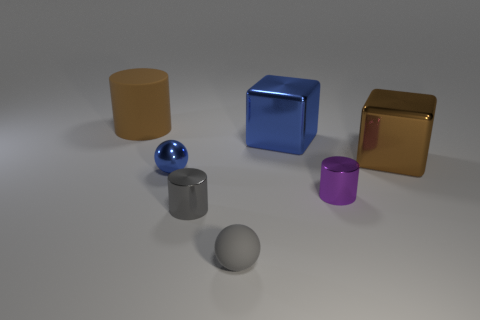What could be the possible use for the objects if they were real? If the objects in the image were real, they could be utilized for various purposes depending on their material properties and sizes. The cylinders might serve as containers or pedestals, the sphere could be a decorative element or part of a game, and the cubes could function as building blocks or contemporary art pieces. And which object seems the heaviest based on their material? Judging by their materials, the shiny gold cube appears to be the heaviest object, assuming it is made of real gold, which is denser and heavier than the other materials typically used for the objects shown. 